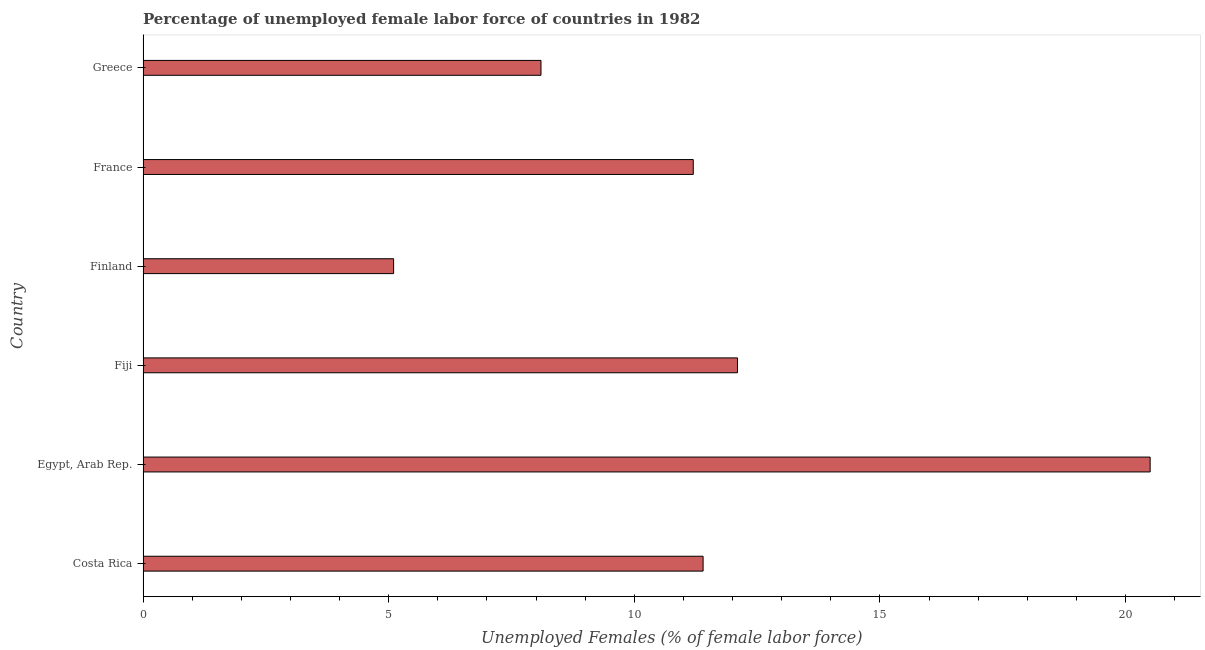Does the graph contain any zero values?
Keep it short and to the point. No. What is the title of the graph?
Make the answer very short. Percentage of unemployed female labor force of countries in 1982. What is the label or title of the X-axis?
Your answer should be very brief. Unemployed Females (% of female labor force). What is the total unemployed female labour force in France?
Provide a short and direct response. 11.2. Across all countries, what is the maximum total unemployed female labour force?
Your answer should be compact. 20.5. Across all countries, what is the minimum total unemployed female labour force?
Make the answer very short. 5.1. In which country was the total unemployed female labour force maximum?
Offer a terse response. Egypt, Arab Rep. What is the sum of the total unemployed female labour force?
Make the answer very short. 68.4. What is the average total unemployed female labour force per country?
Ensure brevity in your answer.  11.4. What is the median total unemployed female labour force?
Offer a terse response. 11.3. What is the ratio of the total unemployed female labour force in Costa Rica to that in Finland?
Make the answer very short. 2.23. What is the difference between the highest and the second highest total unemployed female labour force?
Make the answer very short. 8.4. In how many countries, is the total unemployed female labour force greater than the average total unemployed female labour force taken over all countries?
Give a very brief answer. 2. How many countries are there in the graph?
Provide a succinct answer. 6. Are the values on the major ticks of X-axis written in scientific E-notation?
Offer a very short reply. No. What is the Unemployed Females (% of female labor force) of Costa Rica?
Ensure brevity in your answer.  11.4. What is the Unemployed Females (% of female labor force) of Egypt, Arab Rep.?
Offer a terse response. 20.5. What is the Unemployed Females (% of female labor force) in Fiji?
Keep it short and to the point. 12.1. What is the Unemployed Females (% of female labor force) of Finland?
Keep it short and to the point. 5.1. What is the Unemployed Females (% of female labor force) in France?
Your answer should be very brief. 11.2. What is the Unemployed Females (% of female labor force) in Greece?
Keep it short and to the point. 8.1. What is the difference between the Unemployed Females (% of female labor force) in Costa Rica and Finland?
Your response must be concise. 6.3. What is the difference between the Unemployed Females (% of female labor force) in Costa Rica and France?
Make the answer very short. 0.2. What is the difference between the Unemployed Females (% of female labor force) in Costa Rica and Greece?
Make the answer very short. 3.3. What is the difference between the Unemployed Females (% of female labor force) in Egypt, Arab Rep. and France?
Your answer should be compact. 9.3. What is the difference between the Unemployed Females (% of female labor force) in Fiji and Finland?
Ensure brevity in your answer.  7. What is the difference between the Unemployed Females (% of female labor force) in France and Greece?
Your answer should be very brief. 3.1. What is the ratio of the Unemployed Females (% of female labor force) in Costa Rica to that in Egypt, Arab Rep.?
Provide a short and direct response. 0.56. What is the ratio of the Unemployed Females (% of female labor force) in Costa Rica to that in Fiji?
Make the answer very short. 0.94. What is the ratio of the Unemployed Females (% of female labor force) in Costa Rica to that in Finland?
Provide a succinct answer. 2.23. What is the ratio of the Unemployed Females (% of female labor force) in Costa Rica to that in France?
Offer a terse response. 1.02. What is the ratio of the Unemployed Females (% of female labor force) in Costa Rica to that in Greece?
Make the answer very short. 1.41. What is the ratio of the Unemployed Females (% of female labor force) in Egypt, Arab Rep. to that in Fiji?
Your answer should be very brief. 1.69. What is the ratio of the Unemployed Females (% of female labor force) in Egypt, Arab Rep. to that in Finland?
Your answer should be very brief. 4.02. What is the ratio of the Unemployed Females (% of female labor force) in Egypt, Arab Rep. to that in France?
Give a very brief answer. 1.83. What is the ratio of the Unemployed Females (% of female labor force) in Egypt, Arab Rep. to that in Greece?
Keep it short and to the point. 2.53. What is the ratio of the Unemployed Females (% of female labor force) in Fiji to that in Finland?
Your answer should be compact. 2.37. What is the ratio of the Unemployed Females (% of female labor force) in Fiji to that in Greece?
Make the answer very short. 1.49. What is the ratio of the Unemployed Females (% of female labor force) in Finland to that in France?
Keep it short and to the point. 0.46. What is the ratio of the Unemployed Females (% of female labor force) in Finland to that in Greece?
Make the answer very short. 0.63. What is the ratio of the Unemployed Females (% of female labor force) in France to that in Greece?
Your response must be concise. 1.38. 